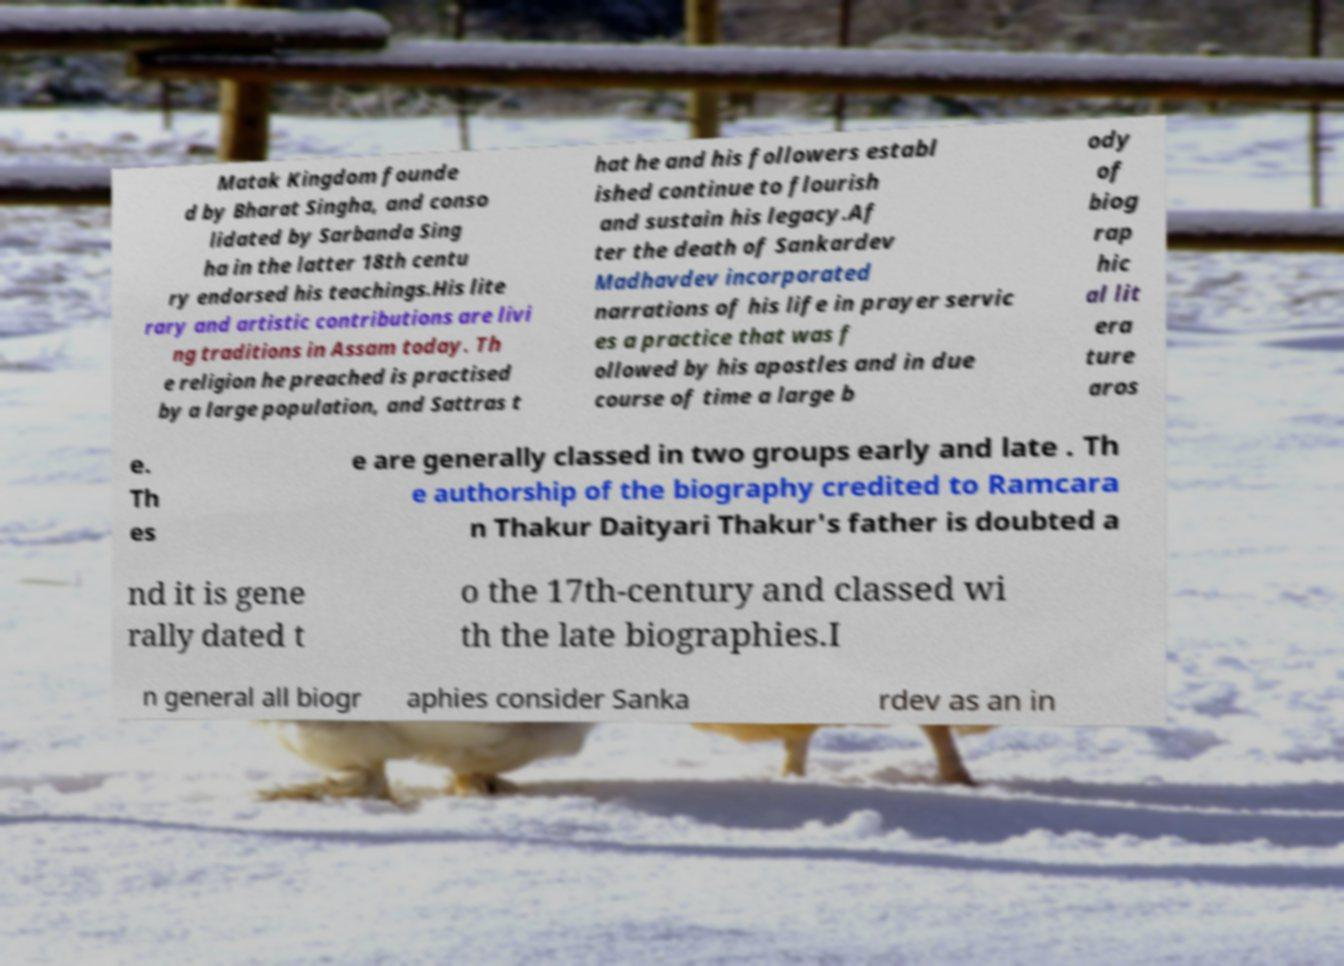Could you extract and type out the text from this image? Matak Kingdom founde d by Bharat Singha, and conso lidated by Sarbanda Sing ha in the latter 18th centu ry endorsed his teachings.His lite rary and artistic contributions are livi ng traditions in Assam today. Th e religion he preached is practised by a large population, and Sattras t hat he and his followers establ ished continue to flourish and sustain his legacy.Af ter the death of Sankardev Madhavdev incorporated narrations of his life in prayer servic es a practice that was f ollowed by his apostles and in due course of time a large b ody of biog rap hic al lit era ture aros e. Th es e are generally classed in two groups early and late . Th e authorship of the biography credited to Ramcara n Thakur Daityari Thakur's father is doubted a nd it is gene rally dated t o the 17th-century and classed wi th the late biographies.I n general all biogr aphies consider Sanka rdev as an in 